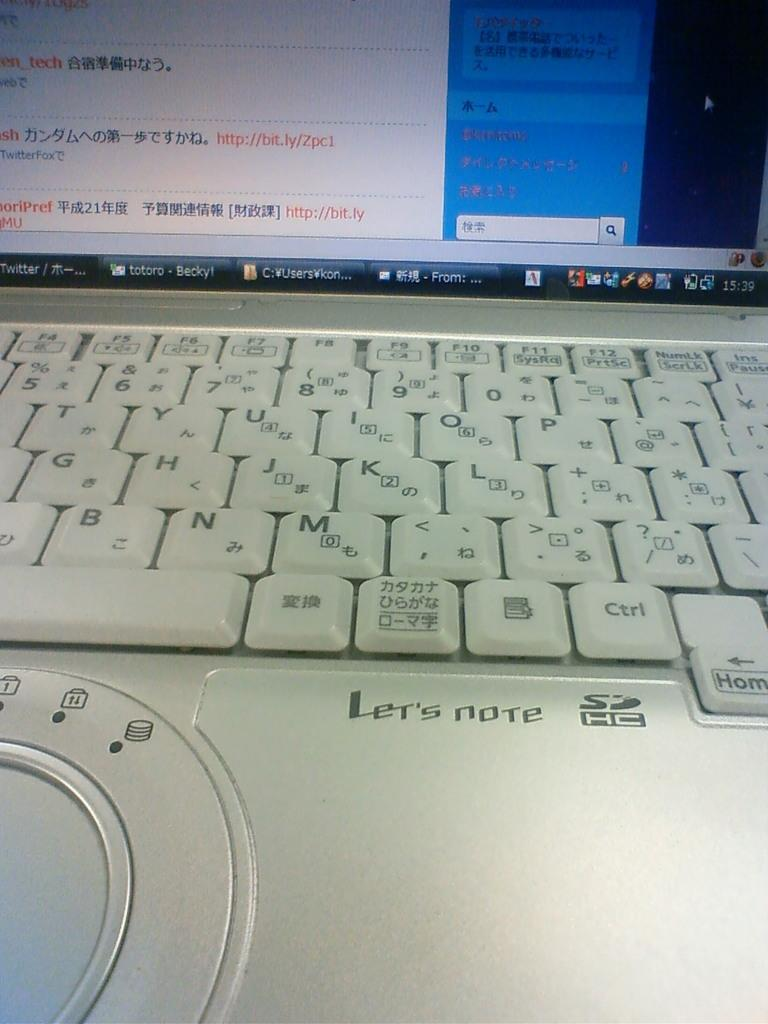<image>
Describe the image concisely. A Lets Note laotop computer with several windows minimized on the screen. 